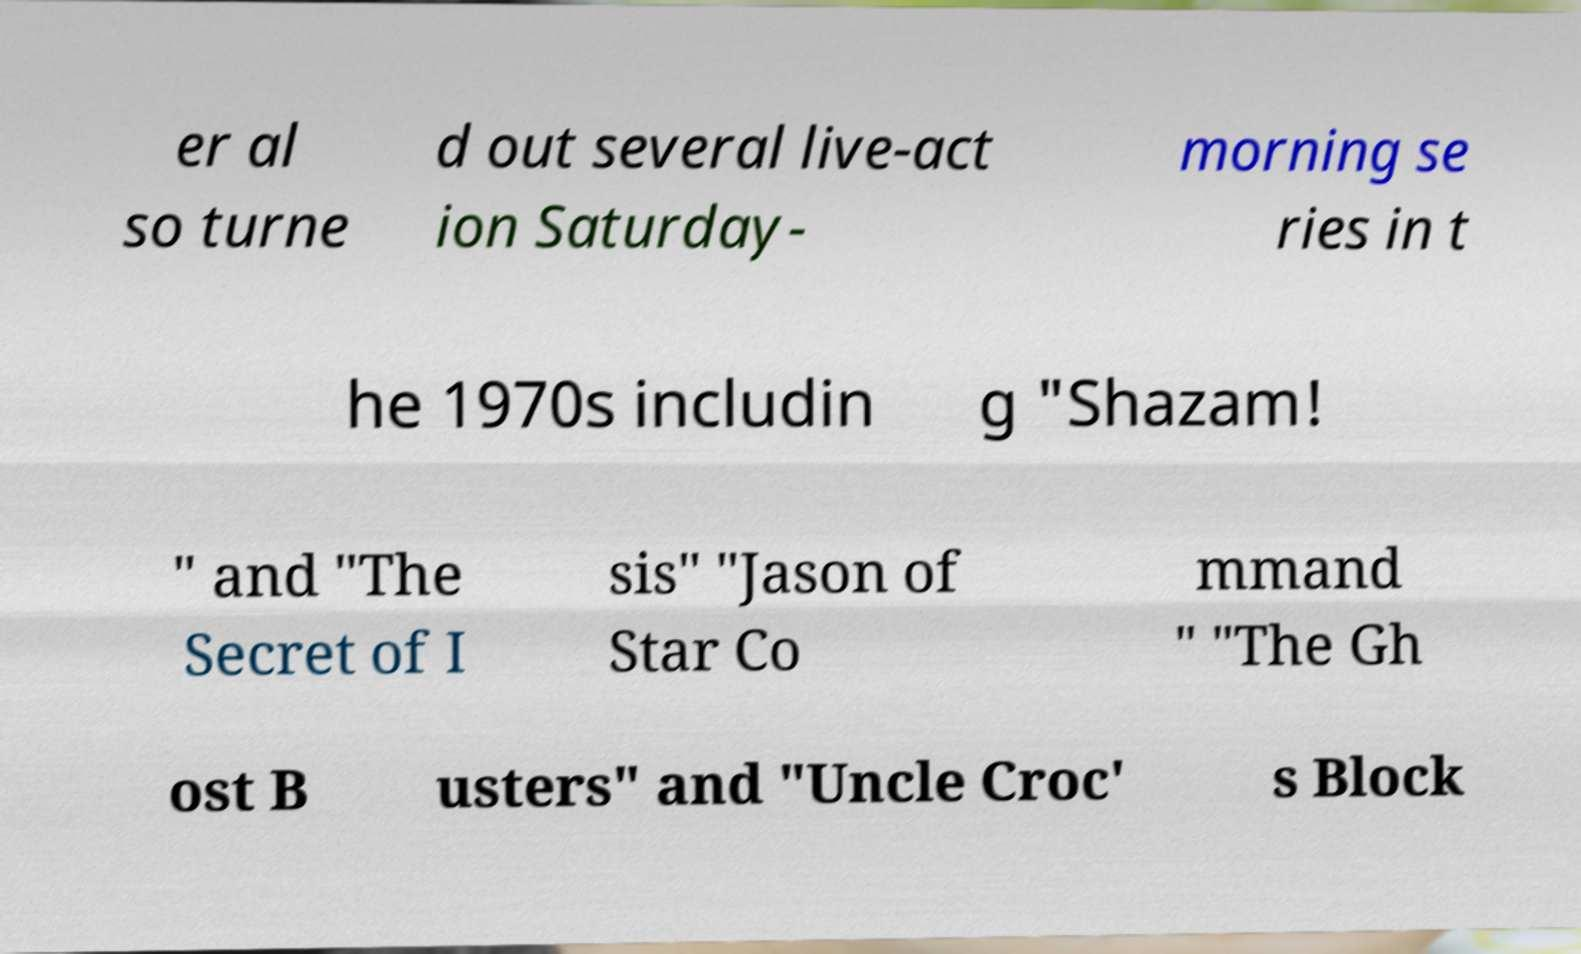Can you accurately transcribe the text from the provided image for me? er al so turne d out several live-act ion Saturday- morning se ries in t he 1970s includin g "Shazam! " and "The Secret of I sis" "Jason of Star Co mmand " "The Gh ost B usters" and "Uncle Croc' s Block 